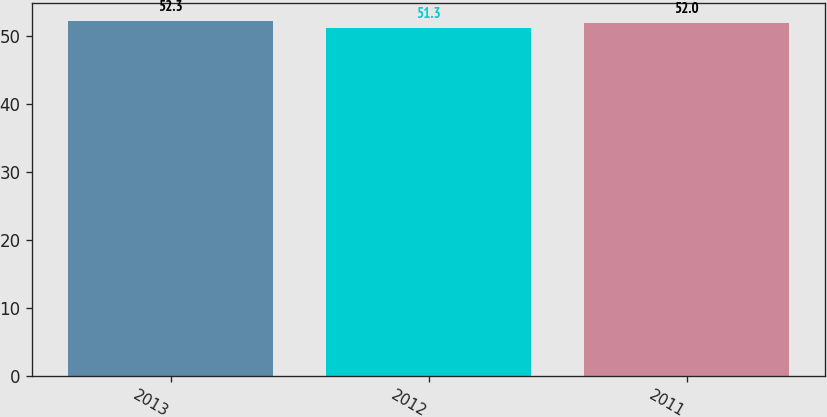<chart> <loc_0><loc_0><loc_500><loc_500><bar_chart><fcel>2013<fcel>2012<fcel>2011<nl><fcel>52.3<fcel>51.3<fcel>52<nl></chart> 